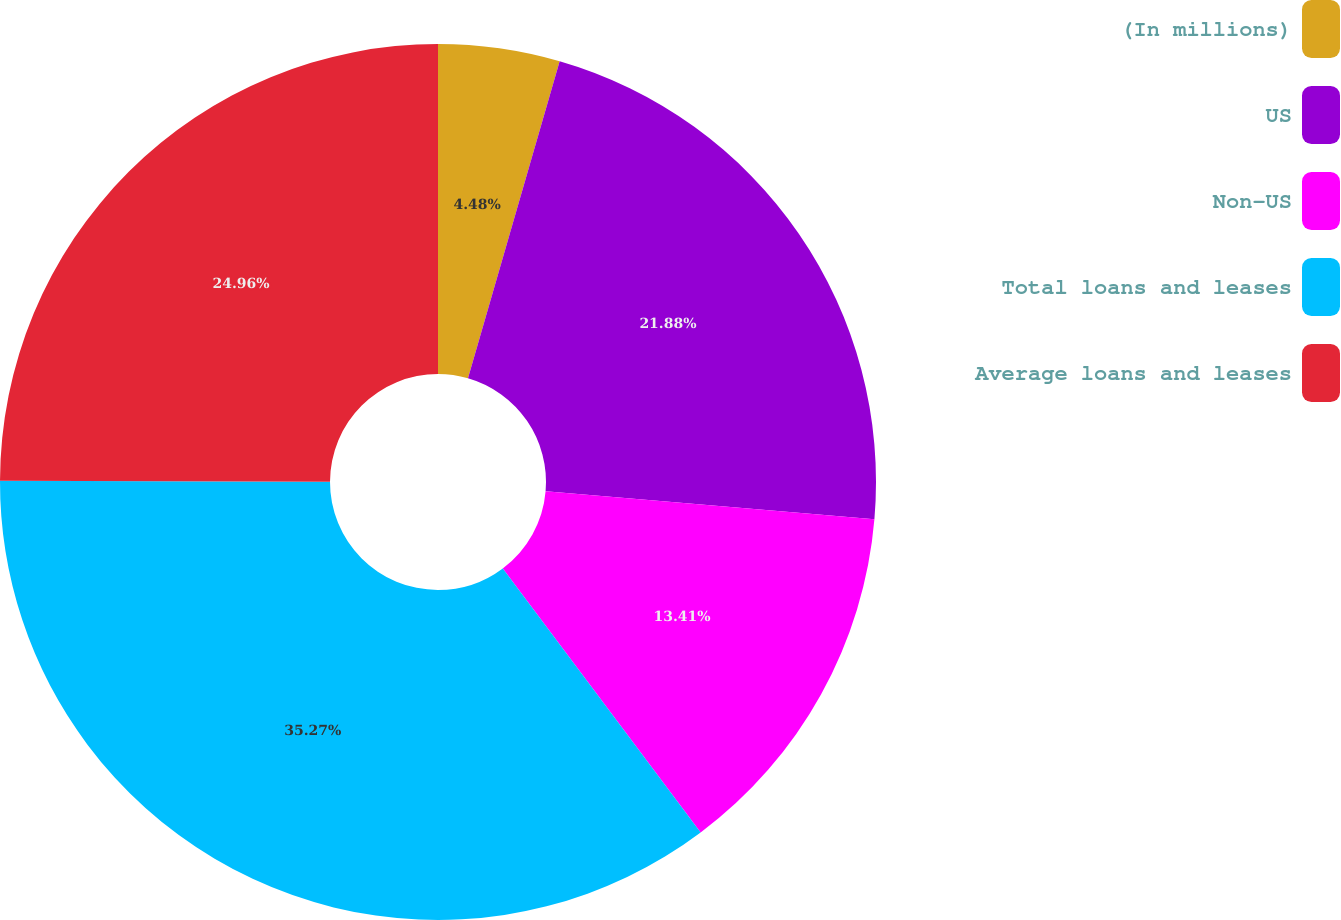<chart> <loc_0><loc_0><loc_500><loc_500><pie_chart><fcel>(In millions)<fcel>US<fcel>Non-US<fcel>Total loans and leases<fcel>Average loans and leases<nl><fcel>4.48%<fcel>21.88%<fcel>13.41%<fcel>35.28%<fcel>24.96%<nl></chart> 